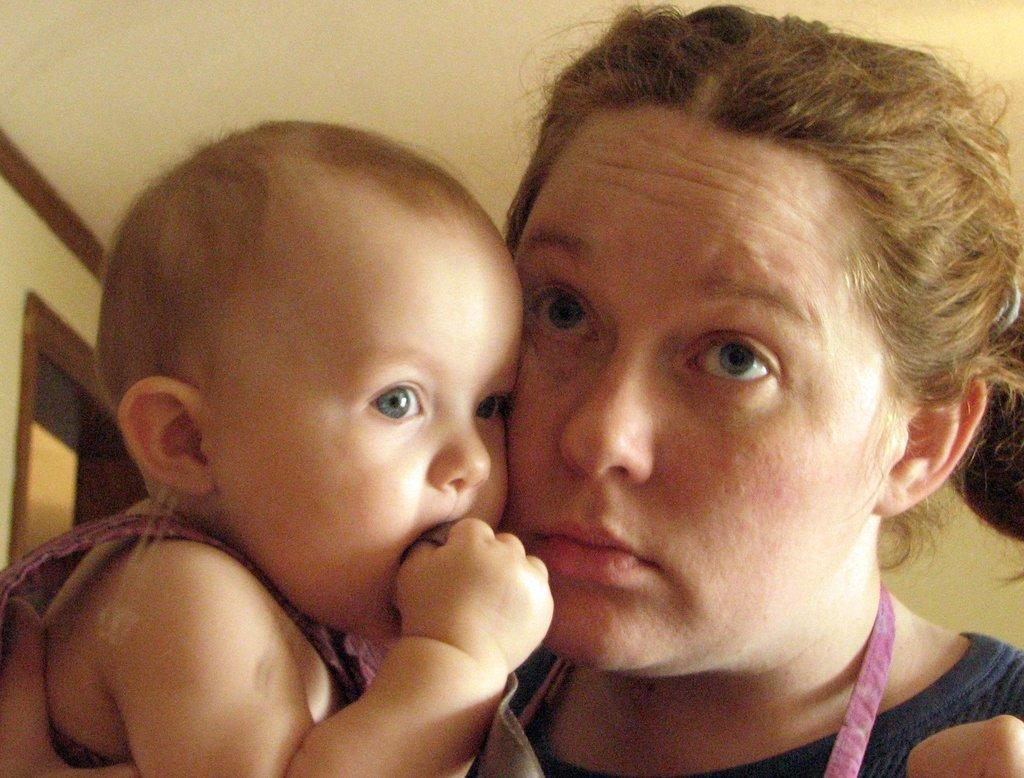Who is the main subject in the image? There is a woman in the image. What is the woman doing in the image? The woman is holding a baby. What can be seen in the background of the image? There is a door visible in the background of the image. What invention is the woman using to hold the baby in the image? There is no invention visible in the image; the woman is simply holding the baby with her arms. 